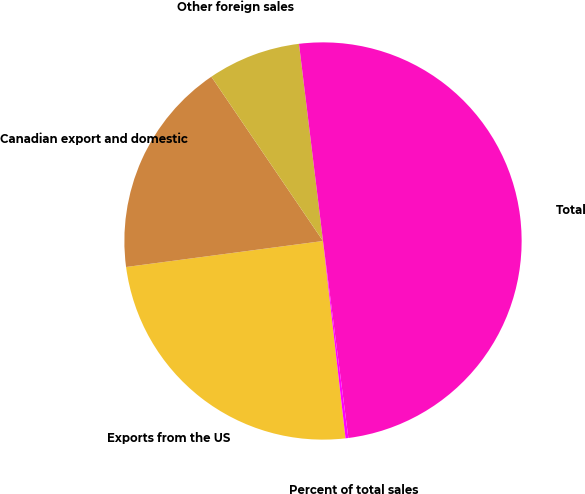<chart> <loc_0><loc_0><loc_500><loc_500><pie_chart><fcel>Exports from the US<fcel>Canadian export and domestic<fcel>Other foreign sales<fcel>Total<fcel>Percent of total sales<nl><fcel>24.72%<fcel>17.59%<fcel>7.57%<fcel>49.89%<fcel>0.23%<nl></chart> 